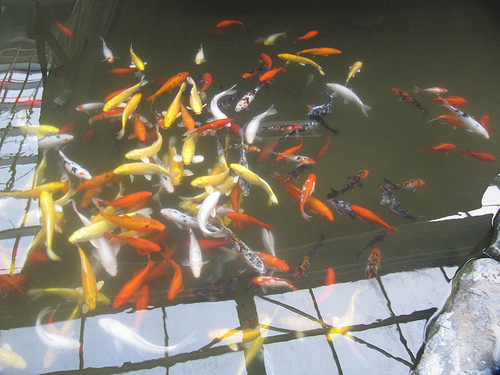<image>
Is the fish in the pond? Yes. The fish is contained within or inside the pond, showing a containment relationship. 